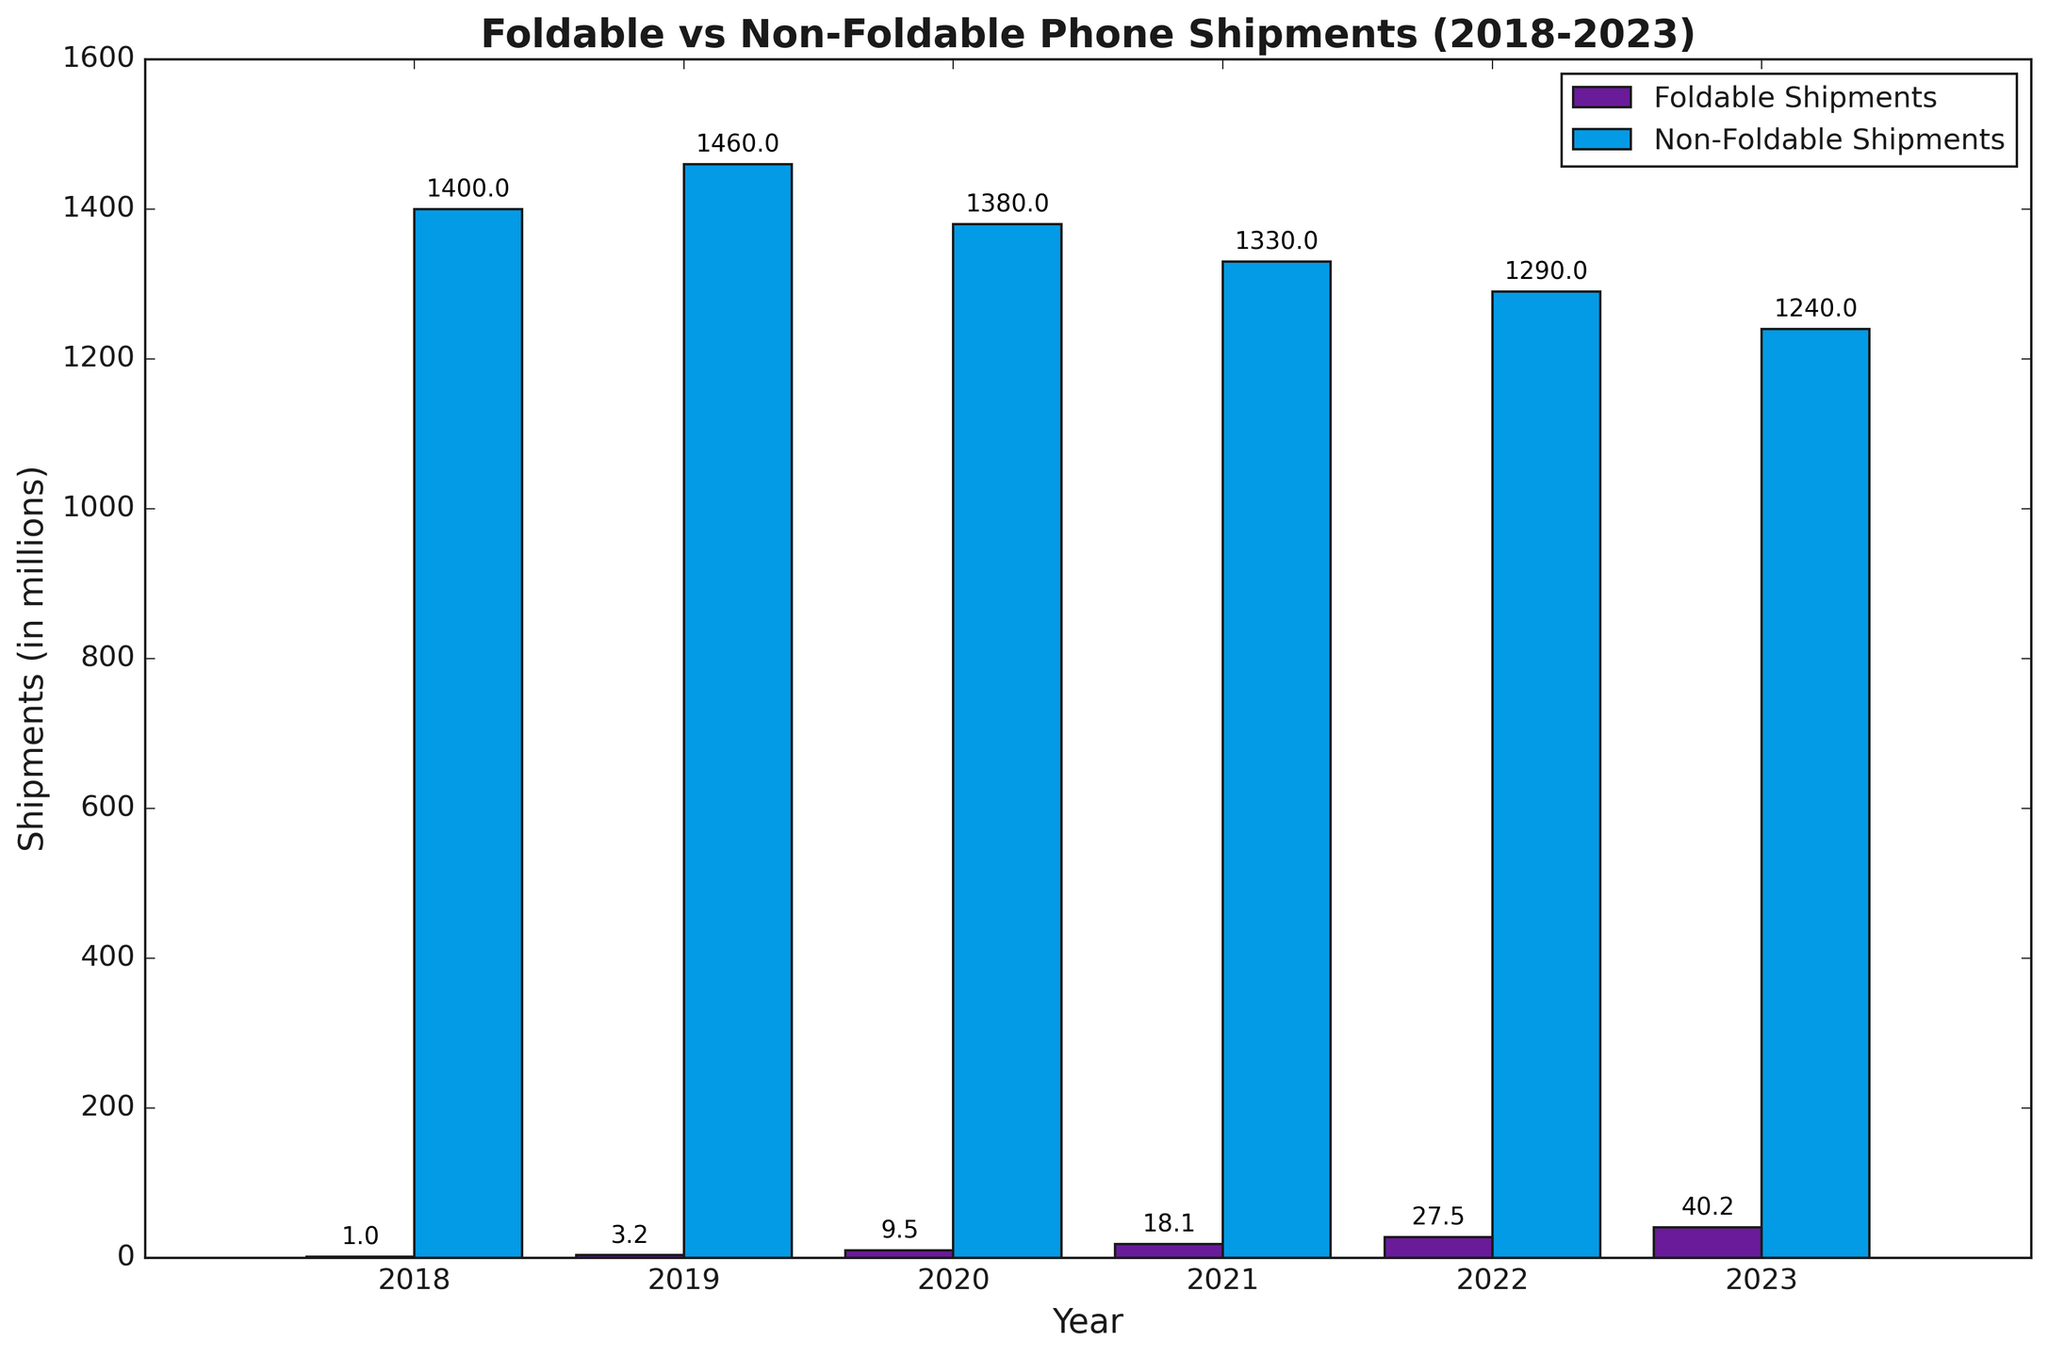折叠屏手机出货量在2023年的值是多少？ 从图中可以看到2023年折叠屏手机出货量是最高的一根紫色柱子，上方标注的值是40.2。
Answer: 40.2 非折叠屏手机出货量哪一年最高？ 图中可以看到蓝色柱子非折叠屏出货量在2019年达到了最高，标示值为1460。
Answer: 2019 2018年至2023年折叠屏手机出货量的总和是多少？ 查照每年折叠屏出货量分别为1.0, 3.2, 9.5, 18.1, 27.5和40.2，加和得到1.0 + 3.2 + 9.5 + 18.1 + 27.5 + 40.2 = 99.5。
Answer: 99.5 2021年折叠屏手机比非折叠屏手机出货量多多少？ 查照2021年折叠屏和非折叠屏出货量分别为18.1和1330，计算差值1330 - 18.1，得出1311.9。
Answer: 1311.9 2022年折叠屏出货量占总出货量百分比是多少？ 查照2022年折叠屏和非折叠屏出货量分别为27.5和1290，总出货量等于27.5 + 1290 = 1317.5，折叠屏占比即27.5 / 1317.5，也即100 * 27.5 / 1317.5 ≈ 2.09%。
Answer: 2.09% 哪一年折叠屏手机出货量增长最迅速？ 查照折叠屏出货量的年增长率，可以看到2019年较2018年增长了3.2-1.0=2.2，2020年较2019年增长了6.3，2021年较2020年增长了8.6，2022年较2021年增长了9.4，2023年较2022年增长了12.7，显然2023年增速最大。
Answer: 2023 两类手机在2022年的总出货量是多少？ 查照2022年折叠屏和非折叠屏出货量分别为27.5和1290，总值等于27.5 + 1290 = 1317.5。
Answer: 1317.5 到2023年底折叠屏手机出货量累计了多少倍于2018年的出货量？ 查照2023年折叠屏手机出货量是40.2，2018年是1.0，相差倍数为40.2 / 1.0 = 40.2倍。
Answer: 40.2 近年来，每年折叠屏手机出货量有没有保持增长？ 查照2018年至2023年折叠屏手机出货量数据，分别为1.0, 3.2, 9.5, 18.1, 27.5和40.2，每年数值依次增加，所以折叠屏手机保持了年年增长。
Answer: 是的 2020年折叠屏与非折叠屏手机出货量的比例是多少？ 查照2020年折叠屏手机出货量为9.5，非折叠屏手机为1380，这两者之比是9.5 / 1380 ≈ 0.00688。
Answer: 0.00688 